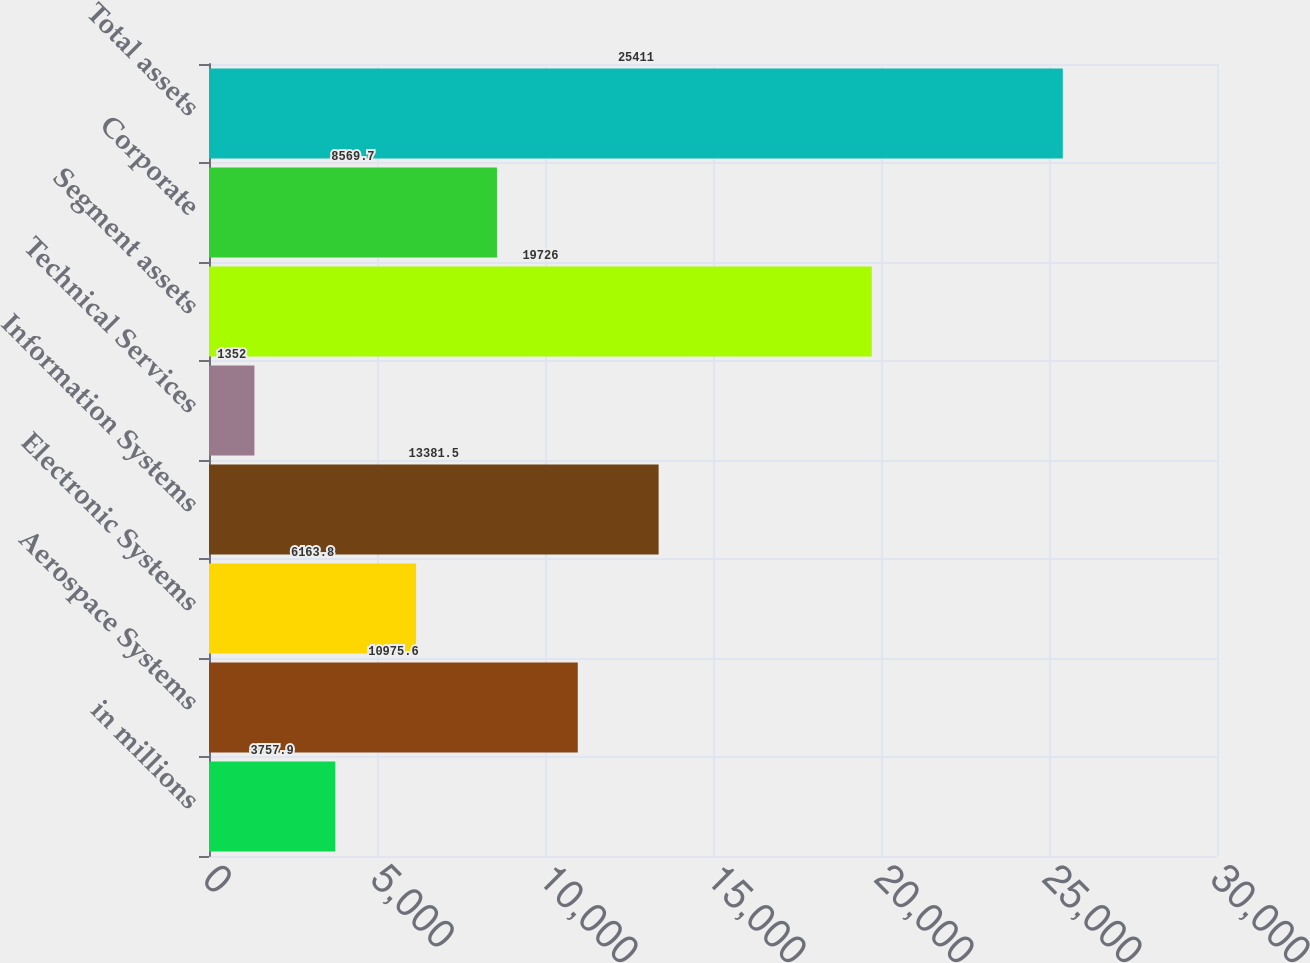Convert chart. <chart><loc_0><loc_0><loc_500><loc_500><bar_chart><fcel>in millions<fcel>Aerospace Systems<fcel>Electronic Systems<fcel>Information Systems<fcel>Technical Services<fcel>Segment assets<fcel>Corporate<fcel>Total assets<nl><fcel>3757.9<fcel>10975.6<fcel>6163.8<fcel>13381.5<fcel>1352<fcel>19726<fcel>8569.7<fcel>25411<nl></chart> 